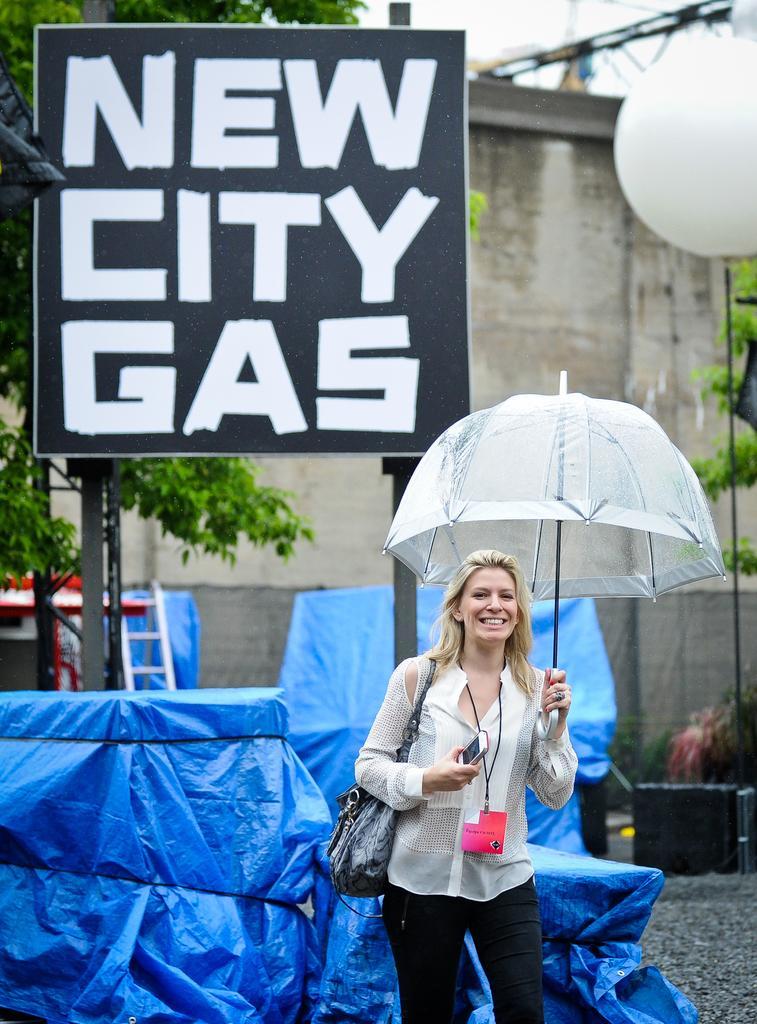Can you describe this image briefly? At the bottom there is a woman wearing a bag and holding an umbrella, behind her there are are blue covers. In the center of the picture there are trees, hoarding, ladder and other objects. In the background there is a building. 